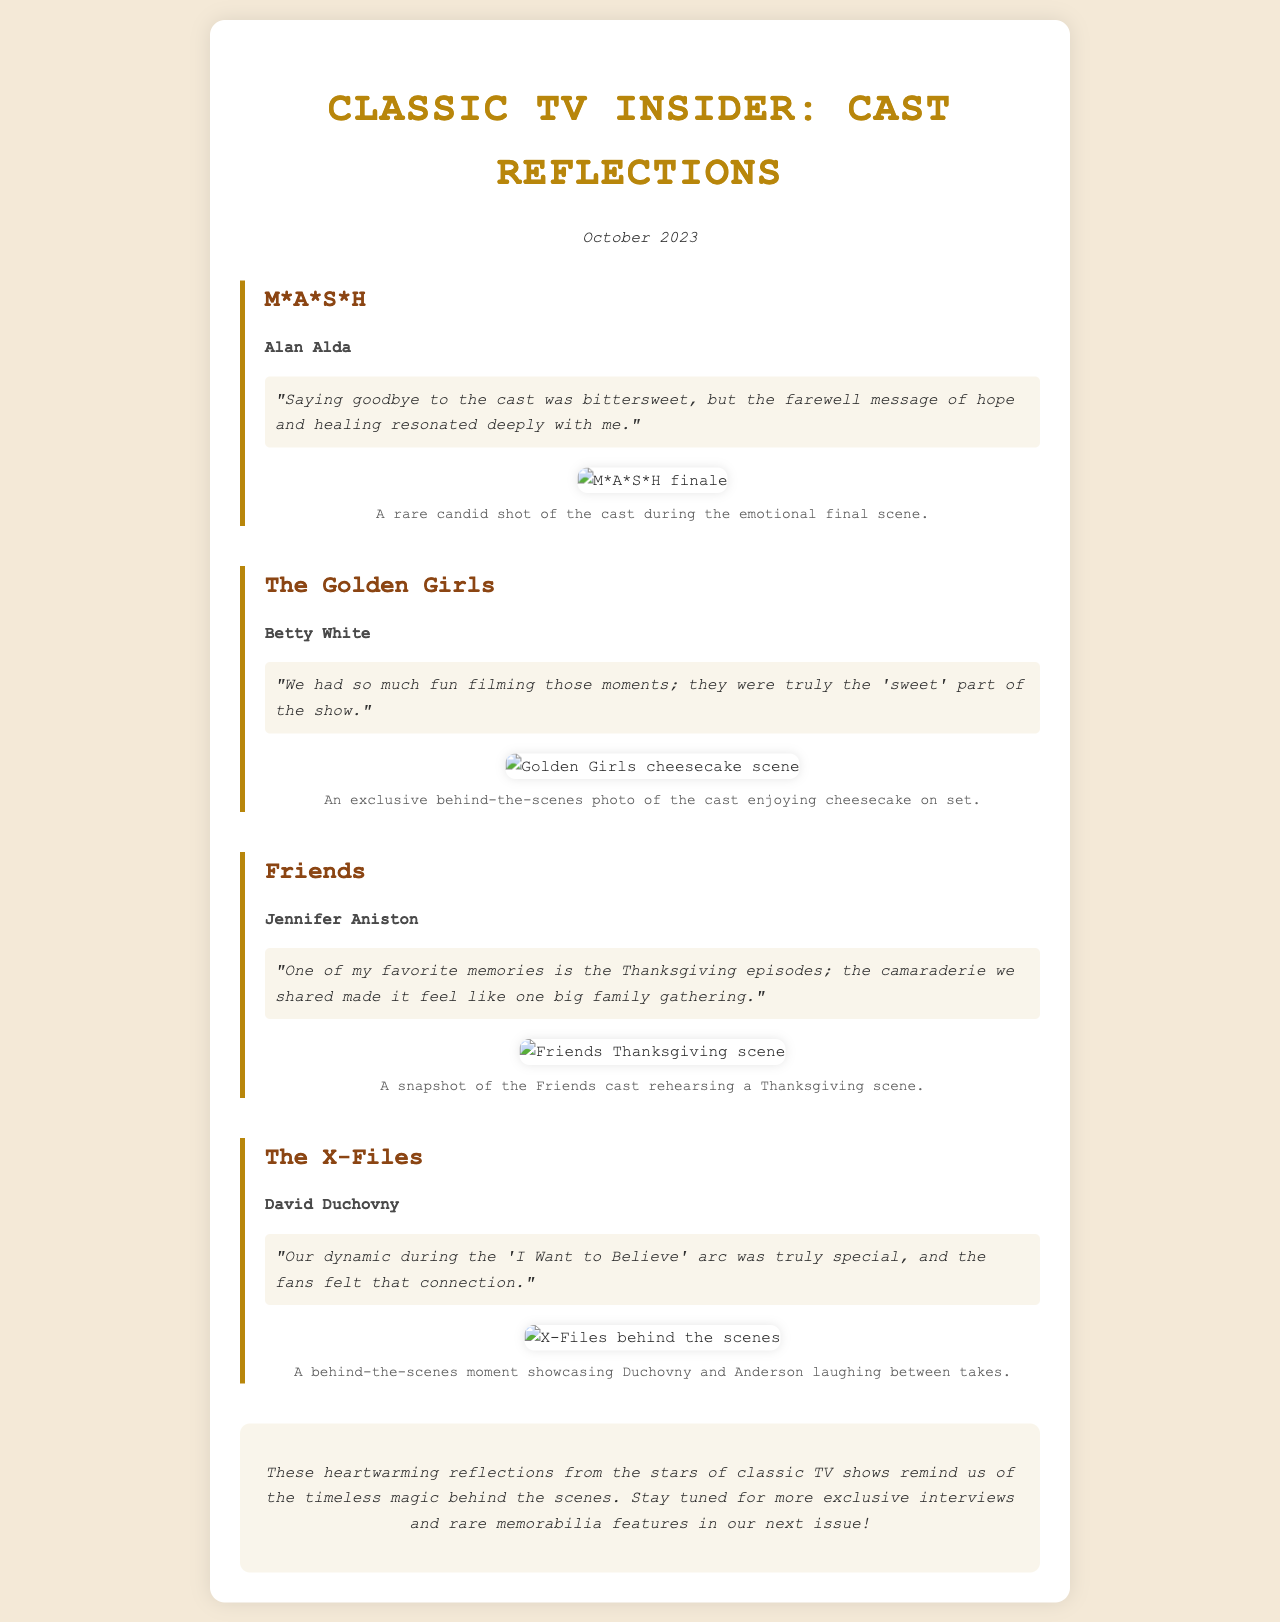what is the title of the newsletter? The title is prominently displayed at the top of the document and is "Classic TV Insider: Cast Reflections."
Answer: Classic TV Insider: Cast Reflections who reflects on their favorite moments from M*A*S*H? The document lists Alan Alda as the cast member reflecting on M*A*S*H.
Answer: Alan Alda what was Betty White's favorite part of filming The Golden Girls? The document states that she enjoyed the fun moments which were the 'sweet' part of the show.
Answer: the 'sweet' part of the show how many interviews are featured in the newsletter? The document contains four interviews with cast members from different shows.
Answer: four what emotional theme does Alan Alda mention about saying goodbye? Alan Alda describes it as bittersweet, indicating a mix of emotions.
Answer: bittersweet which show features Jennifer Aniston's reflections? The document specifically mentions that her reflections are from the show Friends.
Answer: Friends what scene is highlighted with a photo for The X-Files? The photo highlights a behind-the-scenes moment showcasing Duchovny and Anderson laughing.
Answer: behind-the-scenes moment what month and year is this newsletter published? The publication date is stated clearly in the document as October 2023.
Answer: October 2023 what item of memorabilia can readers expect in future issues? The conclusion mentions that readers can expect more exclusive interviews and rare memorabilia features.
Answer: rare memorabilia features 